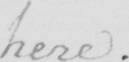Transcribe the text shown in this historical manuscript line. here . 